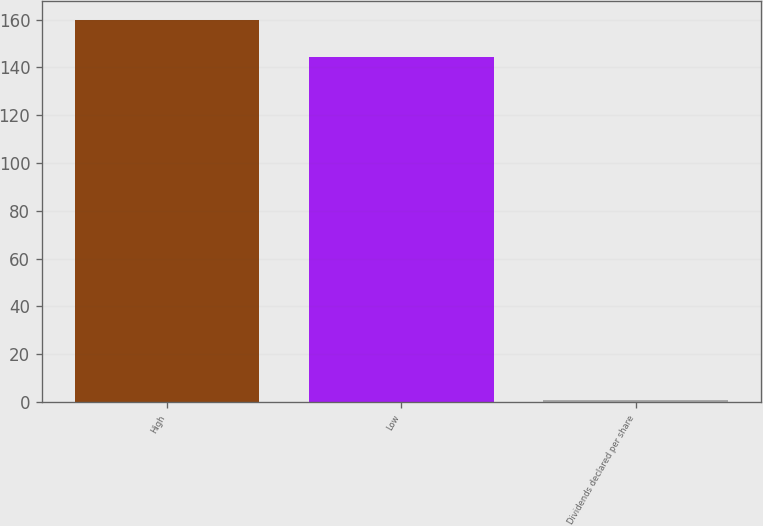<chart> <loc_0><loc_0><loc_500><loc_500><bar_chart><fcel>High<fcel>Low<fcel>Dividends declared per share<nl><fcel>159.94<fcel>144.47<fcel>0.69<nl></chart> 